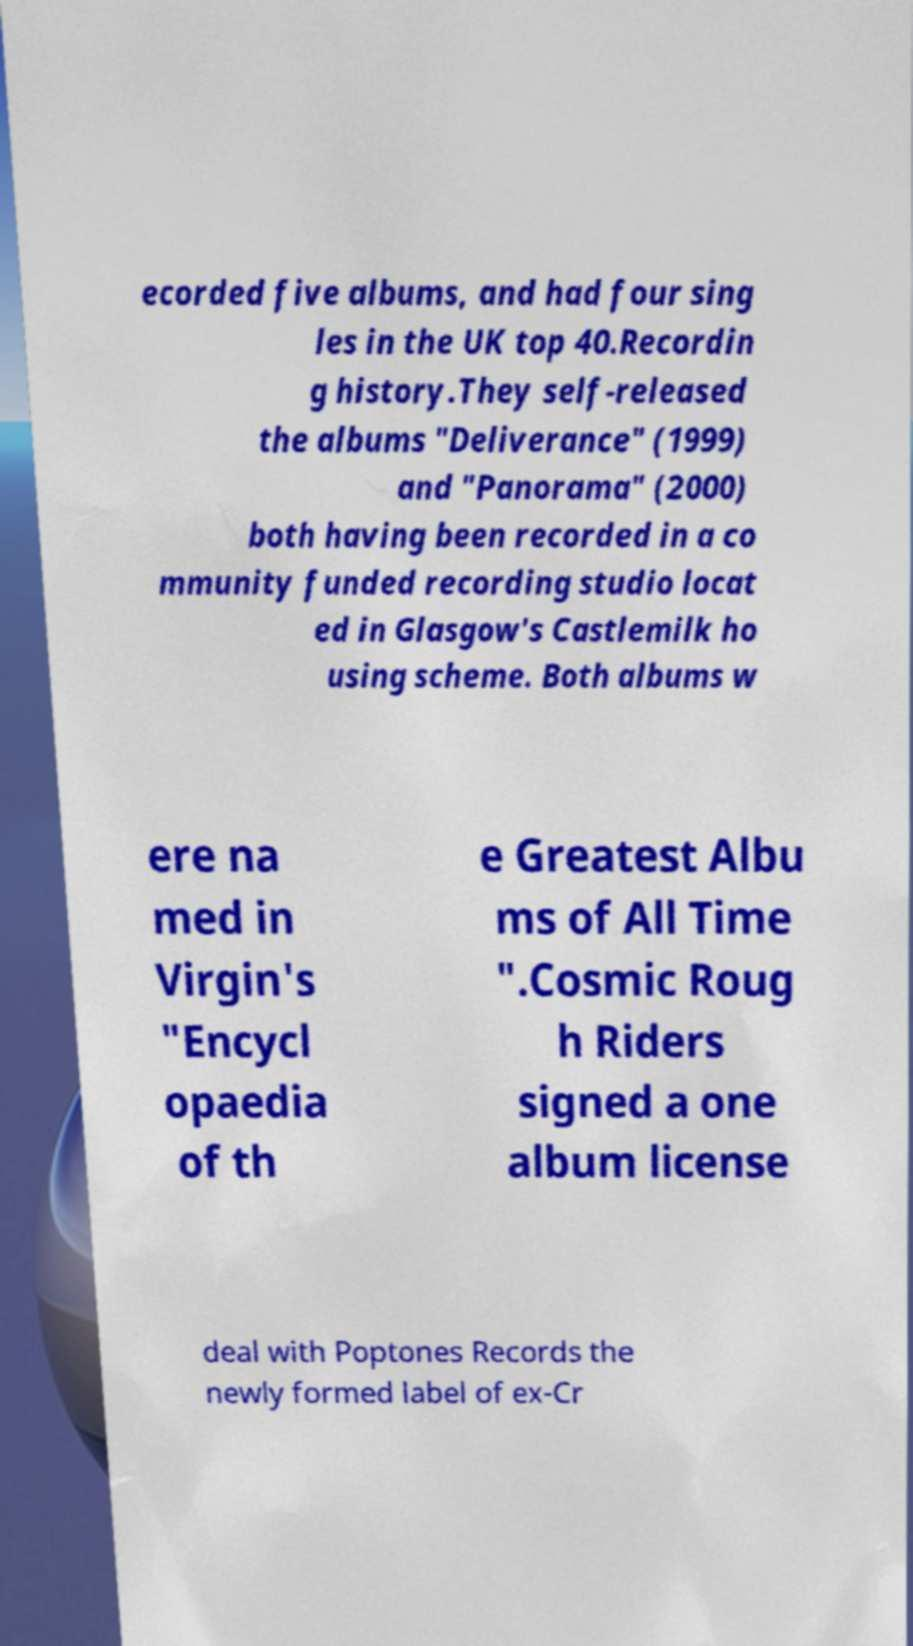There's text embedded in this image that I need extracted. Can you transcribe it verbatim? ecorded five albums, and had four sing les in the UK top 40.Recordin g history.They self-released the albums "Deliverance" (1999) and "Panorama" (2000) both having been recorded in a co mmunity funded recording studio locat ed in Glasgow's Castlemilk ho using scheme. Both albums w ere na med in Virgin's "Encycl opaedia of th e Greatest Albu ms of All Time ".Cosmic Roug h Riders signed a one album license deal with Poptones Records the newly formed label of ex-Cr 